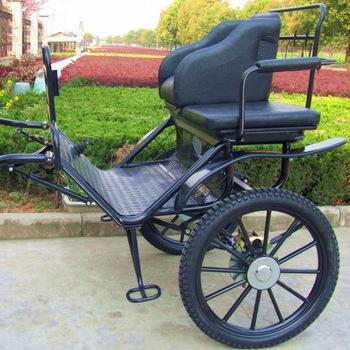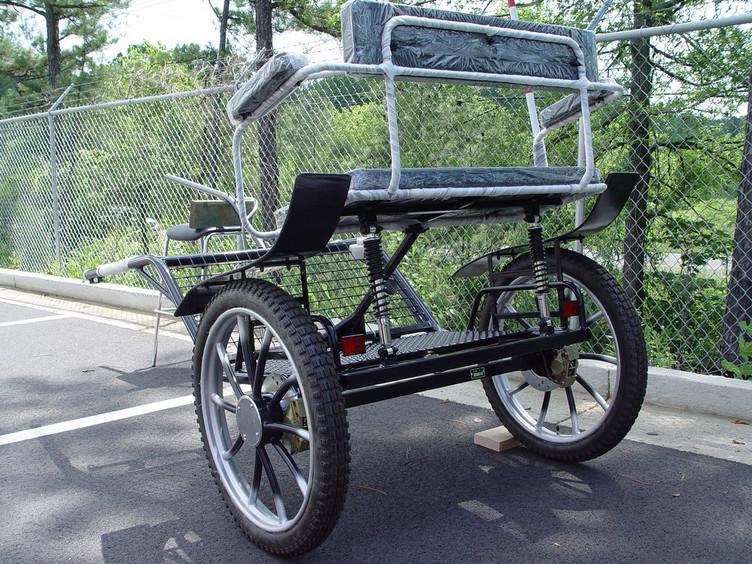The first image is the image on the left, the second image is the image on the right. Considering the images on both sides, is "At least one image shows a cart that is not hooked up to a horse." valid? Answer yes or no. Yes. The first image is the image on the left, the second image is the image on the right. Examine the images to the left and right. Is the description "There is a person in the image on the right." accurate? Answer yes or no. No. 